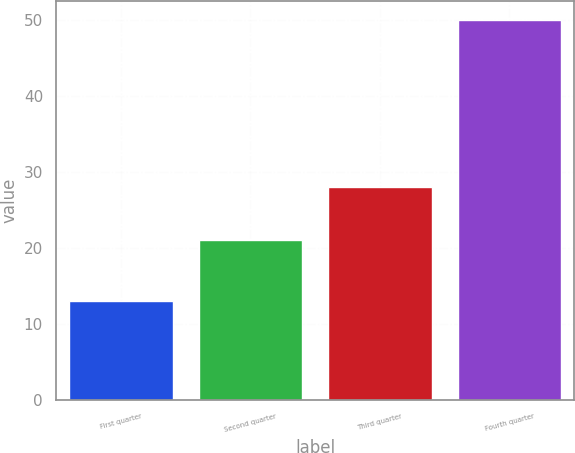Convert chart. <chart><loc_0><loc_0><loc_500><loc_500><bar_chart><fcel>First quarter<fcel>Second quarter<fcel>Third quarter<fcel>Fourth quarter<nl><fcel>13<fcel>21<fcel>28<fcel>50<nl></chart> 